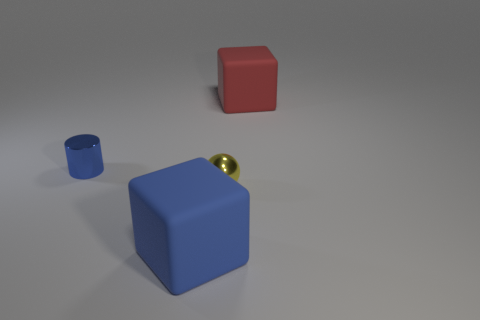There is a object that is the same color as the tiny cylinder; what shape is it?
Provide a succinct answer. Cube. What size is the block that is in front of the small sphere?
Your response must be concise. Large. What material is the blue thing that is to the left of the large rubber thing in front of the tiny yellow shiny sphere?
Make the answer very short. Metal. There is a shiny object to the left of the big block that is in front of the rubber thing that is behind the yellow ball; how big is it?
Provide a short and direct response. Small. Do the yellow object and the blue metallic thing have the same size?
Give a very brief answer. Yes. There is a rubber object that is behind the blue cylinder; is its shape the same as the large matte object that is in front of the metallic cylinder?
Ensure brevity in your answer.  Yes. Is there a cube to the right of the tiny sphere to the right of the blue matte cube?
Offer a very short reply. Yes. Are there any small yellow metallic things?
Provide a succinct answer. Yes. What number of brown things have the same size as the sphere?
Provide a short and direct response. 0. What number of things are behind the large blue matte cube and to the right of the blue shiny cylinder?
Make the answer very short. 2. 